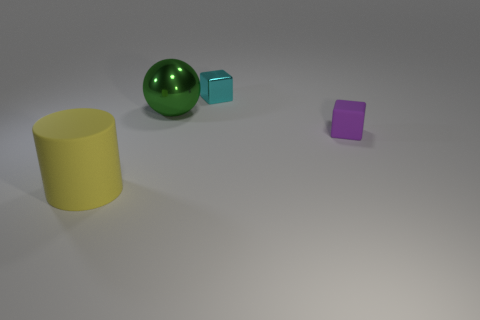Add 3 tiny yellow metal objects. How many objects exist? 7 Subtract all balls. How many objects are left? 3 Add 1 large yellow cylinders. How many large yellow cylinders exist? 2 Subtract 1 green spheres. How many objects are left? 3 Subtract all tiny things. Subtract all big green blocks. How many objects are left? 2 Add 2 yellow cylinders. How many yellow cylinders are left? 3 